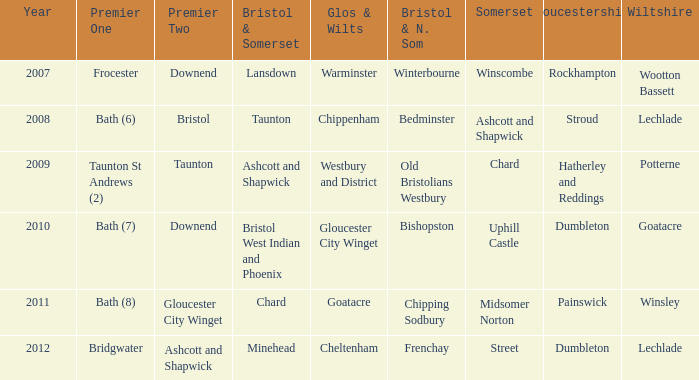What is the somerset for the  year 2009? Chard. 